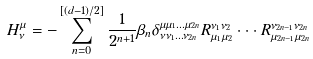Convert formula to latex. <formula><loc_0><loc_0><loc_500><loc_500>H ^ { \mu } _ { \nu } = - \sum _ { n = 0 } ^ { [ ( d - 1 ) / 2 ] } \frac { 1 } { 2 ^ { n + 1 } } \beta _ { n } \delta ^ { \mu \mu _ { 1 } \dots \mu _ { 2 n } } _ { \nu \nu _ { 1 } \dots \nu _ { 2 n } } R ^ { \nu _ { 1 } \nu _ { 2 } } _ { \mu _ { 1 } \mu _ { 2 } } \cdot \cdot \cdot R ^ { \nu _ { 2 n - 1 } \nu _ { 2 n } } _ { \mu _ { 2 n - 1 } \mu _ { 2 n } }</formula> 